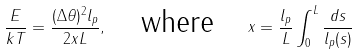<formula> <loc_0><loc_0><loc_500><loc_500>\frac { E } { k T } = \frac { ( \Delta \theta ) ^ { 2 } l _ { p } } { 2 x L } , \quad \text {where} \quad x = \frac { l _ { p } } L \int _ { 0 } ^ { L } \frac { d s } { l _ { p } ( s ) }</formula> 